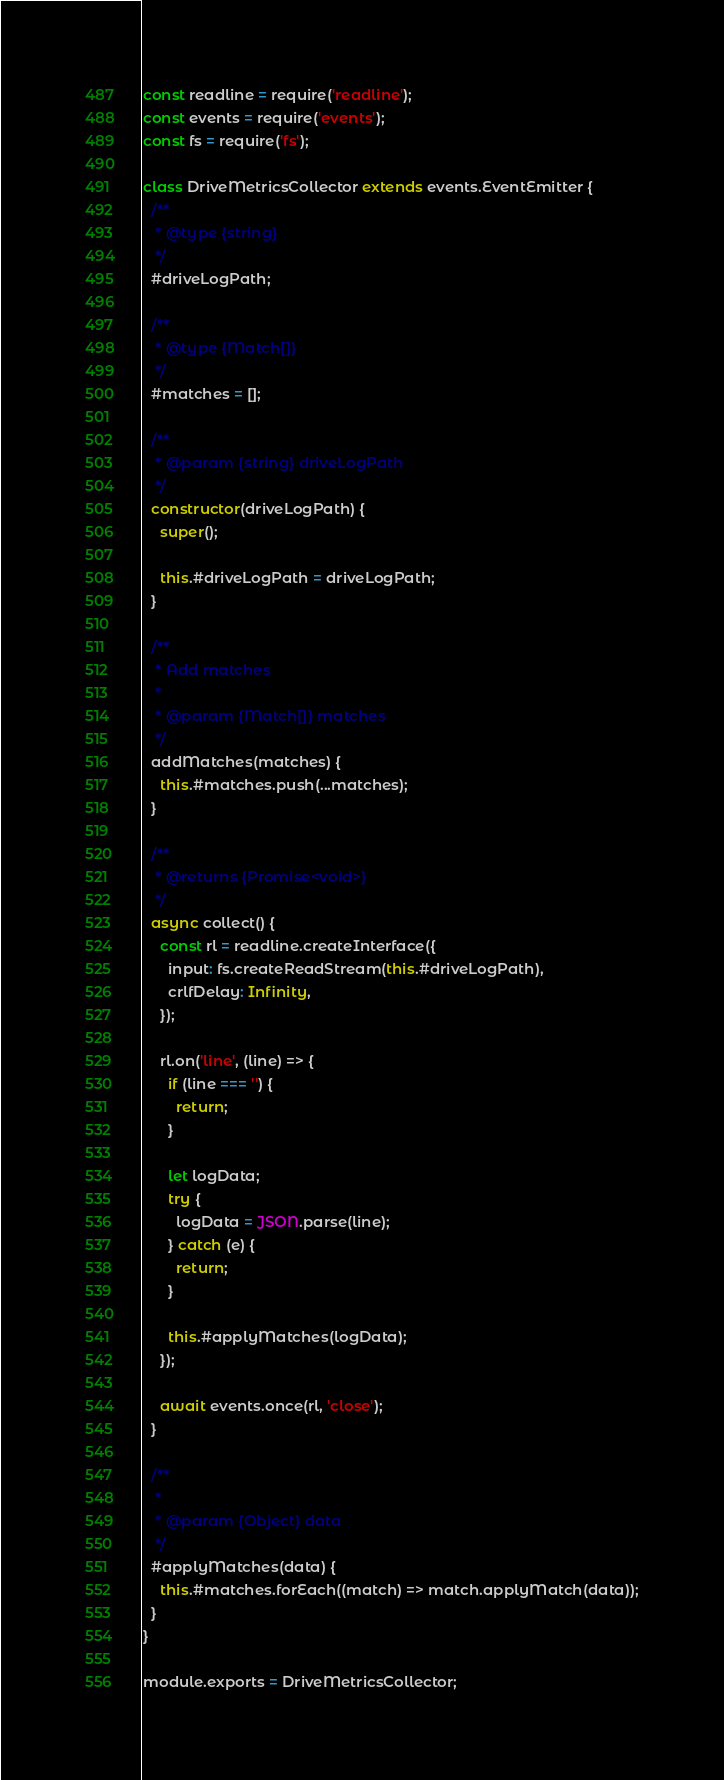<code> <loc_0><loc_0><loc_500><loc_500><_JavaScript_>const readline = require('readline');
const events = require('events');
const fs = require('fs');

class DriveMetricsCollector extends events.EventEmitter {
  /**
   * @type {string}
   */
  #driveLogPath;

  /**
   * @type {Match[]}
   */
  #matches = [];

  /**
   * @param {string} driveLogPath
   */
  constructor(driveLogPath) {
    super();

    this.#driveLogPath = driveLogPath;
  }

  /**
   * Add matches
   *
   * @param {Match[]} matches
   */
  addMatches(matches) {
    this.#matches.push(...matches);
  }

  /**
   * @returns {Promise<void>}
   */
  async collect() {
    const rl = readline.createInterface({
      input: fs.createReadStream(this.#driveLogPath),
      crlfDelay: Infinity,
    });

    rl.on('line', (line) => {
      if (line === '') {
        return;
      }

      let logData;
      try {
        logData = JSON.parse(line);
      } catch (e) {
        return;
      }

      this.#applyMatches(logData);
    });

    await events.once(rl, 'close');
  }

  /**
   *
   * @param {Object} data
   */
  #applyMatches(data) {
    this.#matches.forEach((match) => match.applyMatch(data));
  }
}

module.exports = DriveMetricsCollector;
</code> 